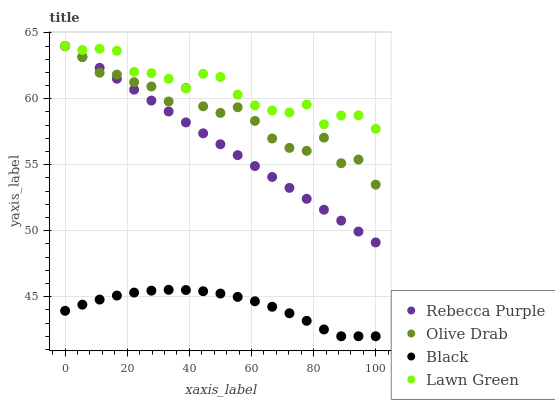Does Black have the minimum area under the curve?
Answer yes or no. Yes. Does Lawn Green have the maximum area under the curve?
Answer yes or no. Yes. Does Rebecca Purple have the minimum area under the curve?
Answer yes or no. No. Does Rebecca Purple have the maximum area under the curve?
Answer yes or no. No. Is Rebecca Purple the smoothest?
Answer yes or no. Yes. Is Olive Drab the roughest?
Answer yes or no. Yes. Is Black the smoothest?
Answer yes or no. No. Is Black the roughest?
Answer yes or no. No. Does Black have the lowest value?
Answer yes or no. Yes. Does Rebecca Purple have the lowest value?
Answer yes or no. No. Does Olive Drab have the highest value?
Answer yes or no. Yes. Does Black have the highest value?
Answer yes or no. No. Is Black less than Rebecca Purple?
Answer yes or no. Yes. Is Olive Drab greater than Black?
Answer yes or no. Yes. Does Olive Drab intersect Lawn Green?
Answer yes or no. Yes. Is Olive Drab less than Lawn Green?
Answer yes or no. No. Is Olive Drab greater than Lawn Green?
Answer yes or no. No. Does Black intersect Rebecca Purple?
Answer yes or no. No. 